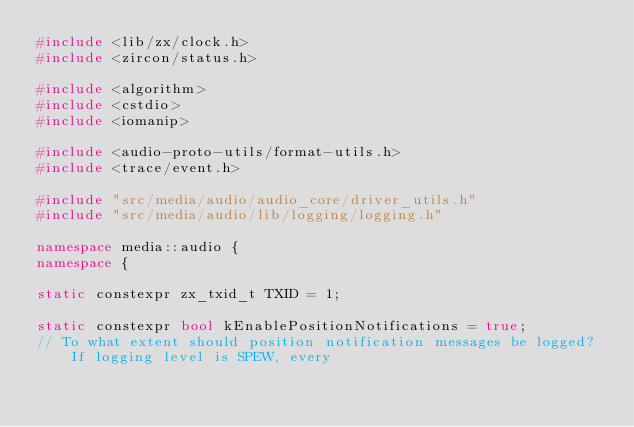<code> <loc_0><loc_0><loc_500><loc_500><_C++_>#include <lib/zx/clock.h>
#include <zircon/status.h>

#include <algorithm>
#include <cstdio>
#include <iomanip>

#include <audio-proto-utils/format-utils.h>
#include <trace/event.h>

#include "src/media/audio/audio_core/driver_utils.h"
#include "src/media/audio/lib/logging/logging.h"

namespace media::audio {
namespace {

static constexpr zx_txid_t TXID = 1;

static constexpr bool kEnablePositionNotifications = true;
// To what extent should position notification messages be logged? If logging level is SPEW, every</code> 